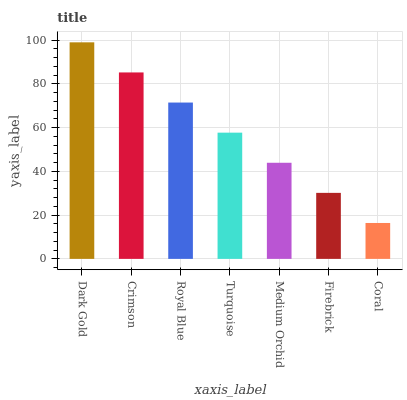Is Coral the minimum?
Answer yes or no. Yes. Is Dark Gold the maximum?
Answer yes or no. Yes. Is Crimson the minimum?
Answer yes or no. No. Is Crimson the maximum?
Answer yes or no. No. Is Dark Gold greater than Crimson?
Answer yes or no. Yes. Is Crimson less than Dark Gold?
Answer yes or no. Yes. Is Crimson greater than Dark Gold?
Answer yes or no. No. Is Dark Gold less than Crimson?
Answer yes or no. No. Is Turquoise the high median?
Answer yes or no. Yes. Is Turquoise the low median?
Answer yes or no. Yes. Is Crimson the high median?
Answer yes or no. No. Is Firebrick the low median?
Answer yes or no. No. 